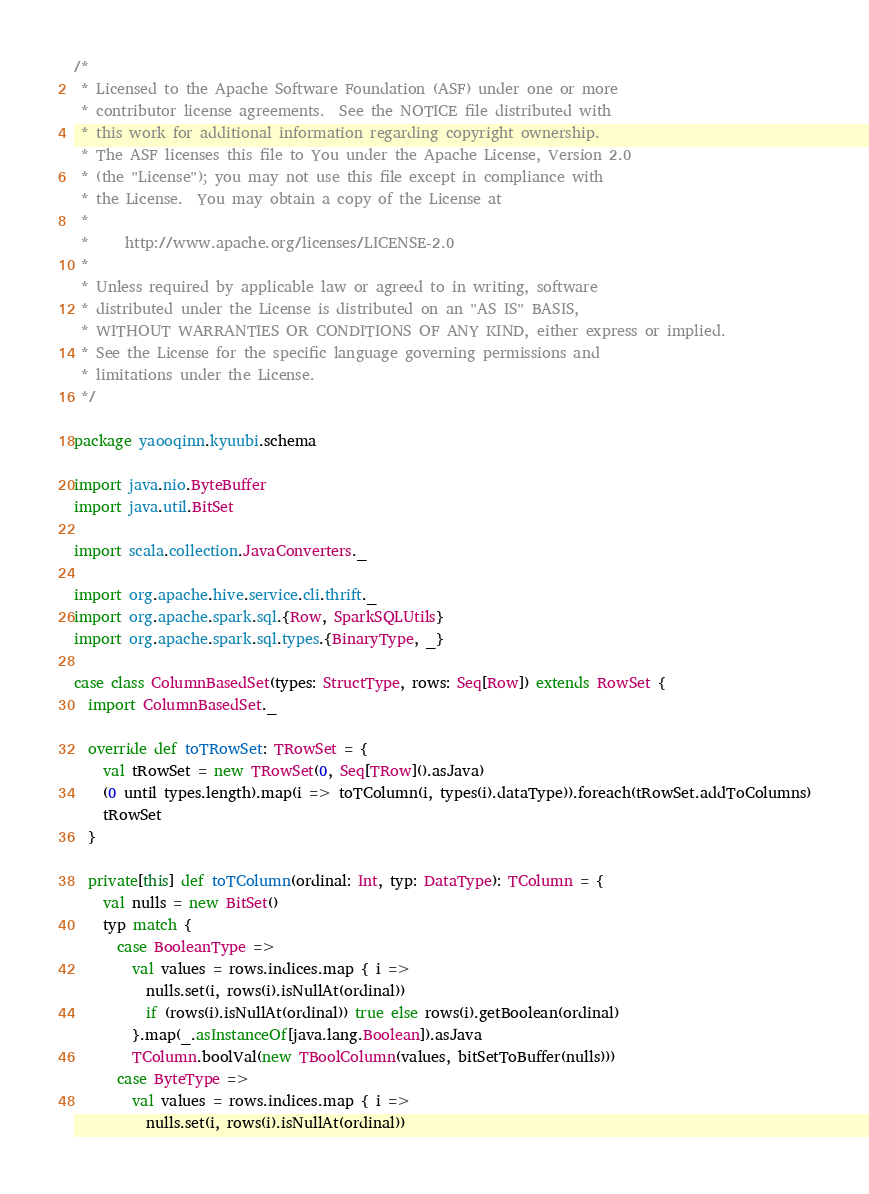Convert code to text. <code><loc_0><loc_0><loc_500><loc_500><_Scala_>/*
 * Licensed to the Apache Software Foundation (ASF) under one or more
 * contributor license agreements.  See the NOTICE file distributed with
 * this work for additional information regarding copyright ownership.
 * The ASF licenses this file to You under the Apache License, Version 2.0
 * (the "License"); you may not use this file except in compliance with
 * the License.  You may obtain a copy of the License at
 *
 *     http://www.apache.org/licenses/LICENSE-2.0
 *
 * Unless required by applicable law or agreed to in writing, software
 * distributed under the License is distributed on an "AS IS" BASIS,
 * WITHOUT WARRANTIES OR CONDITIONS OF ANY KIND, either express or implied.
 * See the License for the specific language governing permissions and
 * limitations under the License.
 */

package yaooqinn.kyuubi.schema

import java.nio.ByteBuffer
import java.util.BitSet

import scala.collection.JavaConverters._

import org.apache.hive.service.cli.thrift._
import org.apache.spark.sql.{Row, SparkSQLUtils}
import org.apache.spark.sql.types.{BinaryType, _}

case class ColumnBasedSet(types: StructType, rows: Seq[Row]) extends RowSet {
  import ColumnBasedSet._

  override def toTRowSet: TRowSet = {
    val tRowSet = new TRowSet(0, Seq[TRow]().asJava)
    (0 until types.length).map(i => toTColumn(i, types(i).dataType)).foreach(tRowSet.addToColumns)
    tRowSet
  }

  private[this] def toTColumn(ordinal: Int, typ: DataType): TColumn = {
    val nulls = new BitSet()
    typ match {
      case BooleanType =>
        val values = rows.indices.map { i =>
          nulls.set(i, rows(i).isNullAt(ordinal))
          if (rows(i).isNullAt(ordinal)) true else rows(i).getBoolean(ordinal)
        }.map(_.asInstanceOf[java.lang.Boolean]).asJava
        TColumn.boolVal(new TBoolColumn(values, bitSetToBuffer(nulls)))
      case ByteType =>
        val values = rows.indices.map { i =>
          nulls.set(i, rows(i).isNullAt(ordinal))</code> 